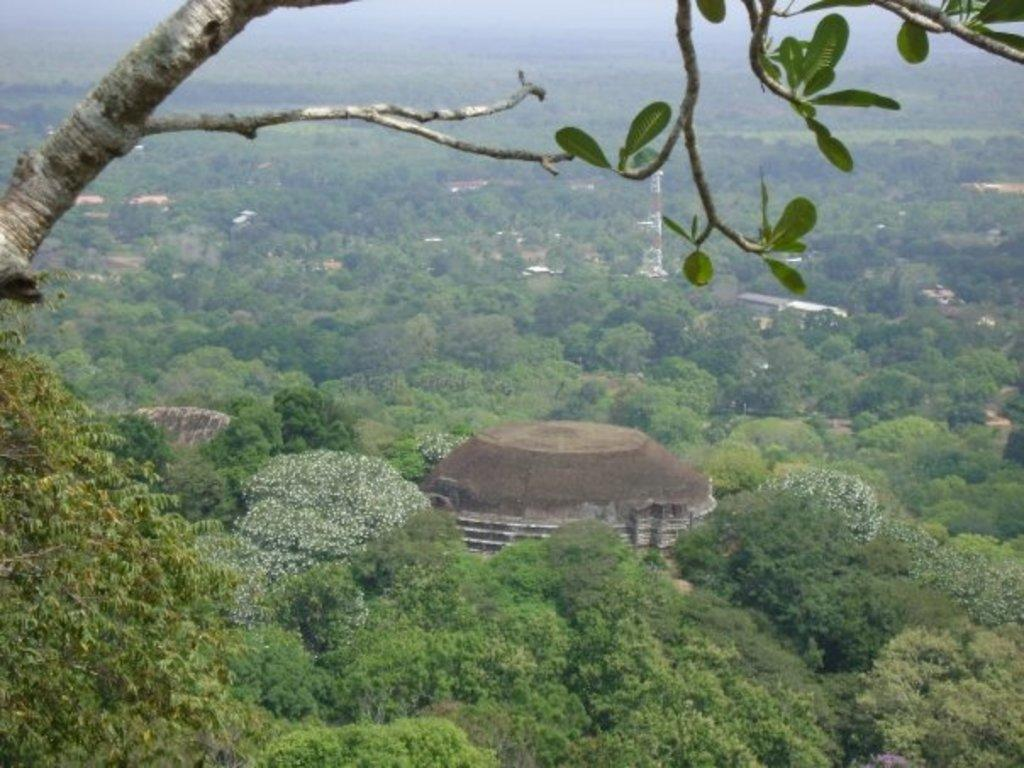What type of natural elements can be seen in the image? There are trees in the image. What type of man-made structures are present in the image? There are buildings and a tower in the image. Where are the plants located in the image? The plants are in the bottom left of the image. What is the condition of the tree in the top left of the image? The tree in the top left of the image has branches and leaves. What sound can be heard coming from the bedroom in the image? There is no bedroom present in the image, so it is not possible to determine what sound might be heard. 